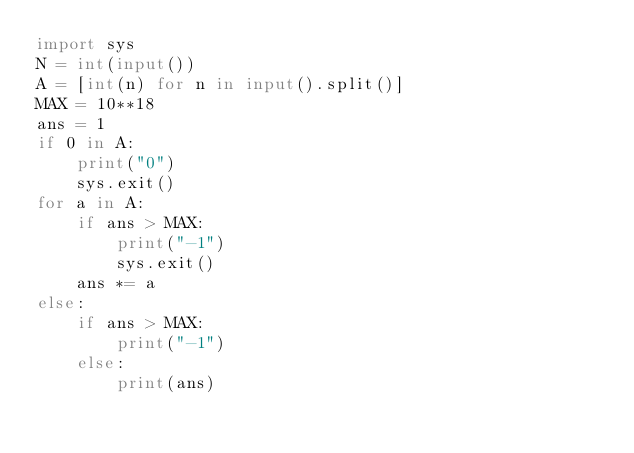Convert code to text. <code><loc_0><loc_0><loc_500><loc_500><_Python_>import sys
N = int(input())
A = [int(n) for n in input().split()]
MAX = 10**18
ans = 1
if 0 in A:
    print("0")
    sys.exit()
for a in A:
    if ans > MAX:
        print("-1")
        sys.exit()
    ans *= a
else:
    if ans > MAX:
        print("-1")
    else:
        print(ans)</code> 